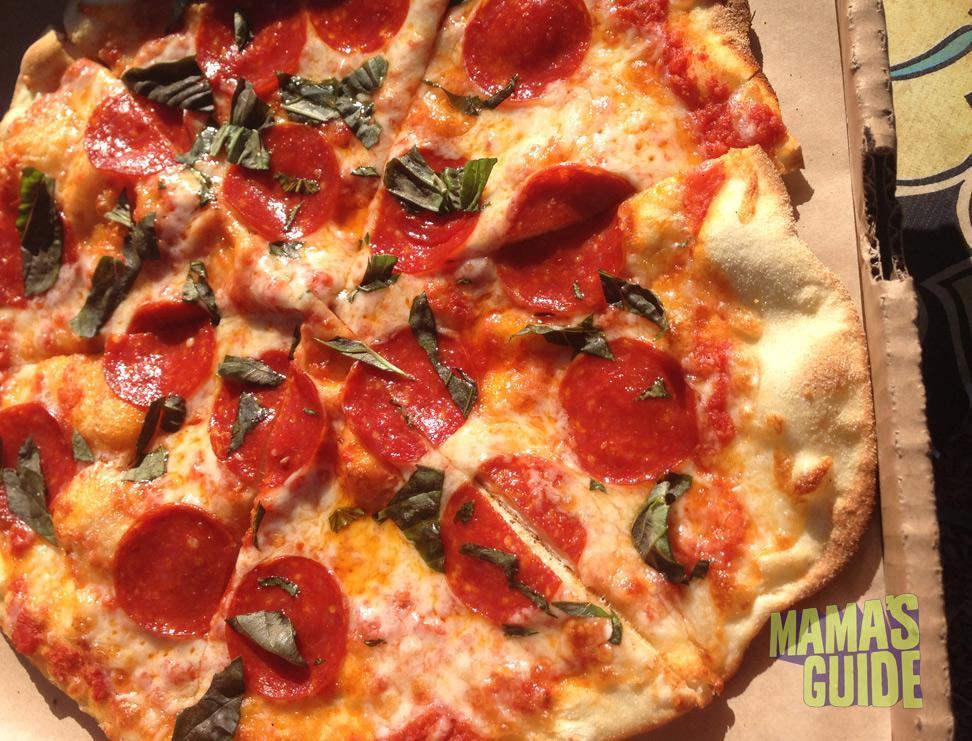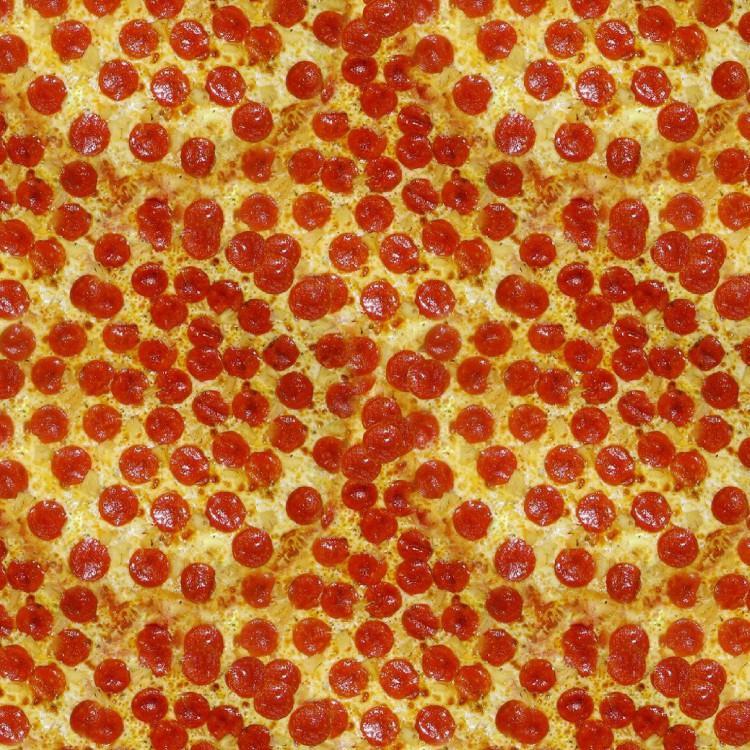The first image is the image on the left, the second image is the image on the right. Assess this claim about the two images: "A sliced pizza topped with pepperonis and green bits is in an open brown cardboard box in one image.". Correct or not? Answer yes or no. Yes. 